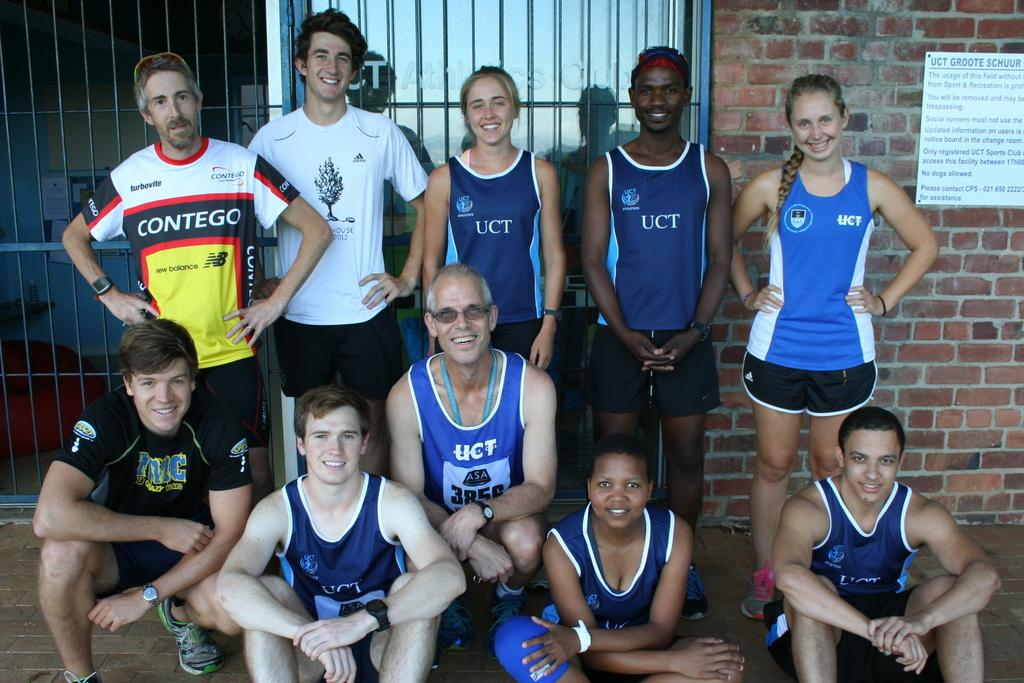<image>
Offer a succinct explanation of the picture presented. A group of athletes where some are wearing shirts from UCT. 